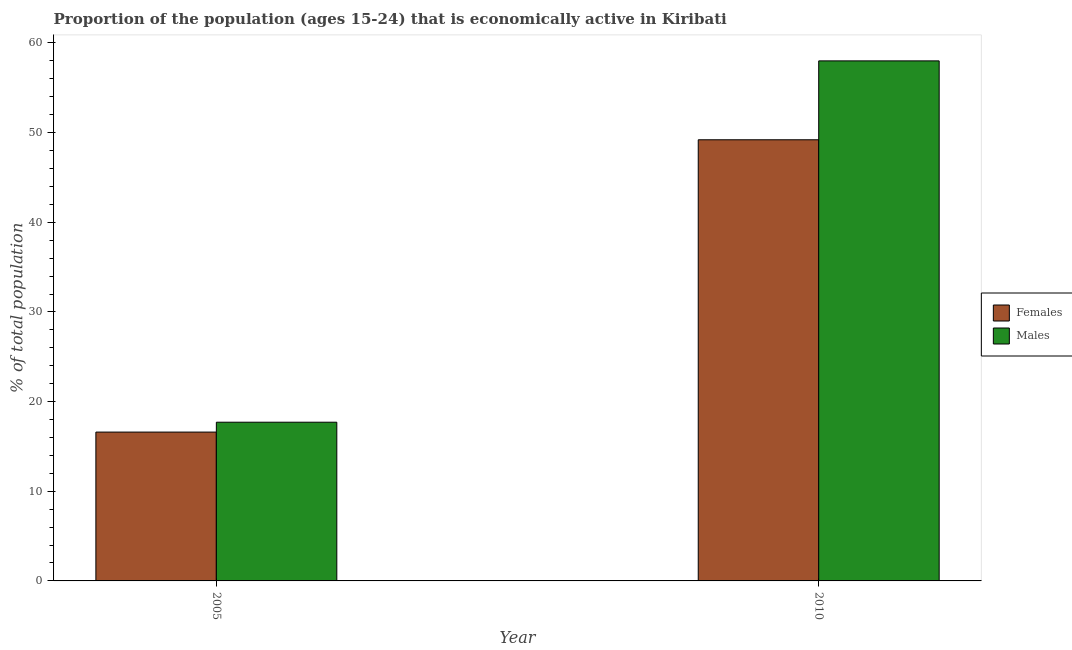How many groups of bars are there?
Offer a terse response. 2. Are the number of bars per tick equal to the number of legend labels?
Your answer should be very brief. Yes. Are the number of bars on each tick of the X-axis equal?
Ensure brevity in your answer.  Yes. How many bars are there on the 1st tick from the left?
Ensure brevity in your answer.  2. What is the label of the 1st group of bars from the left?
Your answer should be compact. 2005. What is the percentage of economically active male population in 2005?
Your response must be concise. 17.7. Across all years, what is the maximum percentage of economically active female population?
Ensure brevity in your answer.  49.2. Across all years, what is the minimum percentage of economically active male population?
Provide a succinct answer. 17.7. In which year was the percentage of economically active male population maximum?
Give a very brief answer. 2010. What is the total percentage of economically active male population in the graph?
Ensure brevity in your answer.  75.7. What is the difference between the percentage of economically active male population in 2005 and that in 2010?
Ensure brevity in your answer.  -40.3. What is the difference between the percentage of economically active male population in 2005 and the percentage of economically active female population in 2010?
Your answer should be very brief. -40.3. What is the average percentage of economically active male population per year?
Give a very brief answer. 37.85. In the year 2010, what is the difference between the percentage of economically active female population and percentage of economically active male population?
Provide a succinct answer. 0. In how many years, is the percentage of economically active female population greater than 24 %?
Provide a succinct answer. 1. What is the ratio of the percentage of economically active male population in 2005 to that in 2010?
Provide a short and direct response. 0.31. Is the percentage of economically active male population in 2005 less than that in 2010?
Keep it short and to the point. Yes. What does the 2nd bar from the left in 2005 represents?
Your answer should be very brief. Males. What does the 2nd bar from the right in 2005 represents?
Your response must be concise. Females. How many years are there in the graph?
Offer a terse response. 2. Are the values on the major ticks of Y-axis written in scientific E-notation?
Keep it short and to the point. No. Does the graph contain any zero values?
Offer a terse response. No. Does the graph contain grids?
Your response must be concise. No. Where does the legend appear in the graph?
Keep it short and to the point. Center right. What is the title of the graph?
Your response must be concise. Proportion of the population (ages 15-24) that is economically active in Kiribati. What is the label or title of the X-axis?
Ensure brevity in your answer.  Year. What is the label or title of the Y-axis?
Keep it short and to the point. % of total population. What is the % of total population in Females in 2005?
Your response must be concise. 16.6. What is the % of total population in Males in 2005?
Give a very brief answer. 17.7. What is the % of total population in Females in 2010?
Give a very brief answer. 49.2. What is the % of total population of Males in 2010?
Provide a short and direct response. 58. Across all years, what is the maximum % of total population in Females?
Keep it short and to the point. 49.2. Across all years, what is the maximum % of total population of Males?
Your response must be concise. 58. Across all years, what is the minimum % of total population in Females?
Offer a terse response. 16.6. Across all years, what is the minimum % of total population in Males?
Make the answer very short. 17.7. What is the total % of total population of Females in the graph?
Provide a short and direct response. 65.8. What is the total % of total population of Males in the graph?
Provide a short and direct response. 75.7. What is the difference between the % of total population in Females in 2005 and that in 2010?
Your answer should be very brief. -32.6. What is the difference between the % of total population of Males in 2005 and that in 2010?
Make the answer very short. -40.3. What is the difference between the % of total population of Females in 2005 and the % of total population of Males in 2010?
Your response must be concise. -41.4. What is the average % of total population in Females per year?
Make the answer very short. 32.9. What is the average % of total population of Males per year?
Offer a very short reply. 37.85. What is the ratio of the % of total population of Females in 2005 to that in 2010?
Give a very brief answer. 0.34. What is the ratio of the % of total population in Males in 2005 to that in 2010?
Your response must be concise. 0.31. What is the difference between the highest and the second highest % of total population in Females?
Provide a short and direct response. 32.6. What is the difference between the highest and the second highest % of total population in Males?
Your response must be concise. 40.3. What is the difference between the highest and the lowest % of total population in Females?
Make the answer very short. 32.6. What is the difference between the highest and the lowest % of total population of Males?
Provide a short and direct response. 40.3. 